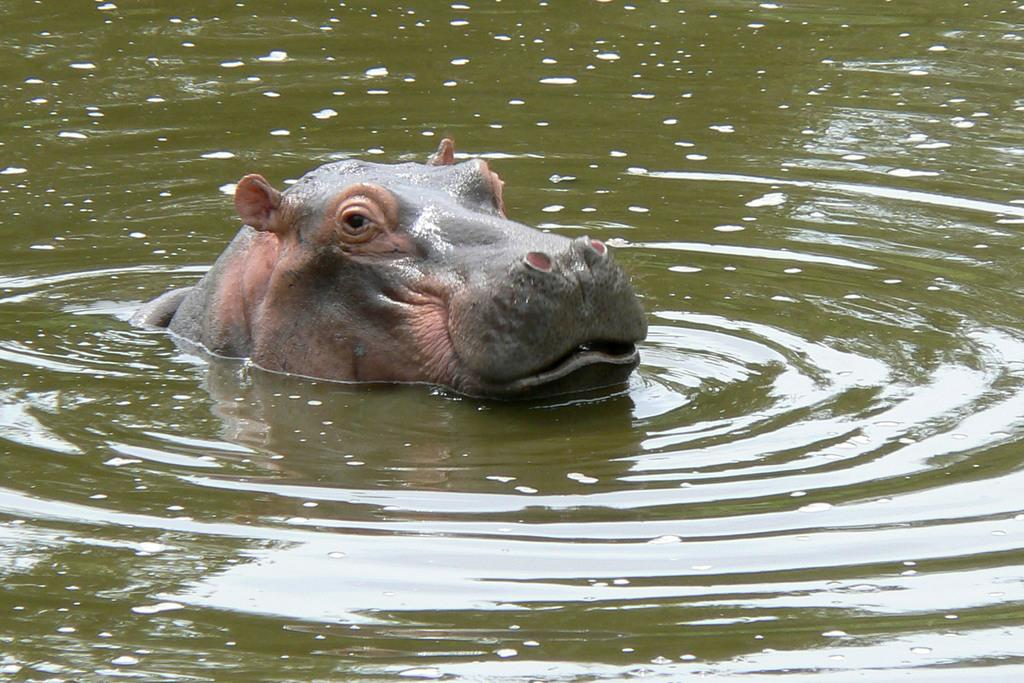What is the animal doing in the water? The fact provided does not specify what the animal is doing in the water. Can you describe the lighting conditions in the image? The image was likely taken during the day, as there is no mention of darkness or artificial lighting. What type of paper is being used to dry the animal's teeth in the image? There is no paper or teeth visible in the image, as it features an animal in the water. How many apples are being held by the animal in the image? There are no apples present in the image; it only shows an animal in the water. 